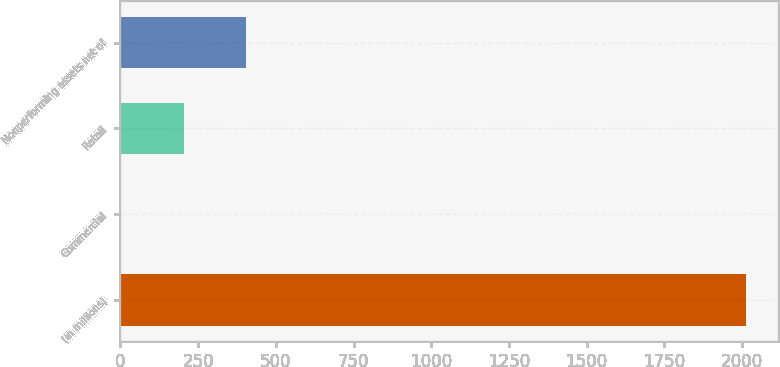Convert chart. <chart><loc_0><loc_0><loc_500><loc_500><bar_chart><fcel>(in millions)<fcel>Commercial<fcel>Retail<fcel>Nonperforming assets net of<nl><fcel>2014<fcel>3<fcel>204.1<fcel>405.2<nl></chart> 